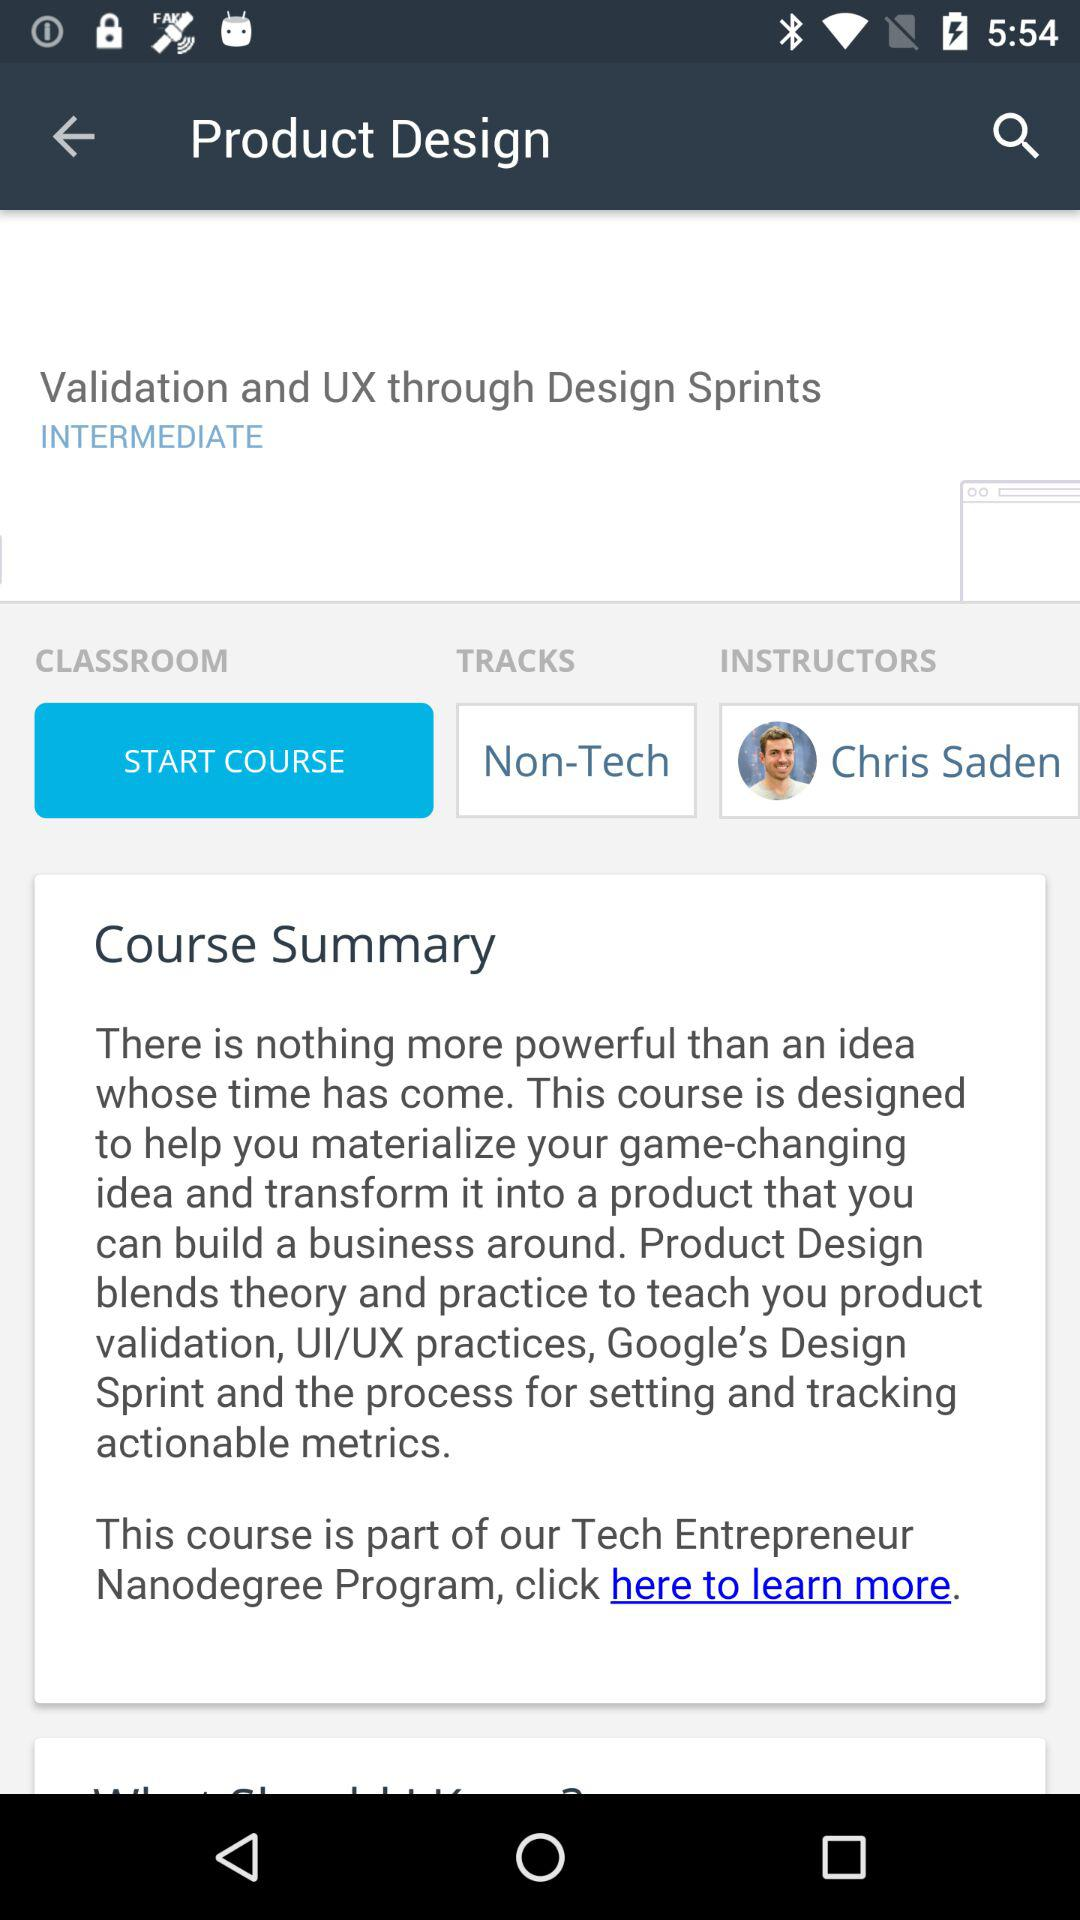Which program includes the "Product Design" course? The program that includes the "Product Design" course is the "Tech Entrepreneur Nanodegree". 